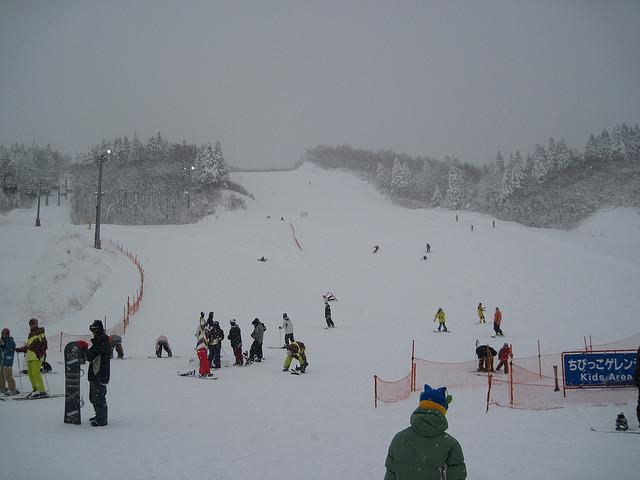Why is this hill so small? Please explain your reasoning. for children. The sign labeling the hill says it is a kids' area. 